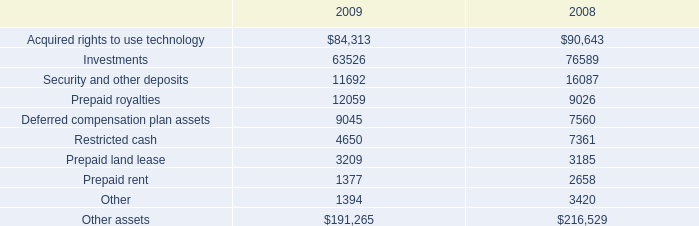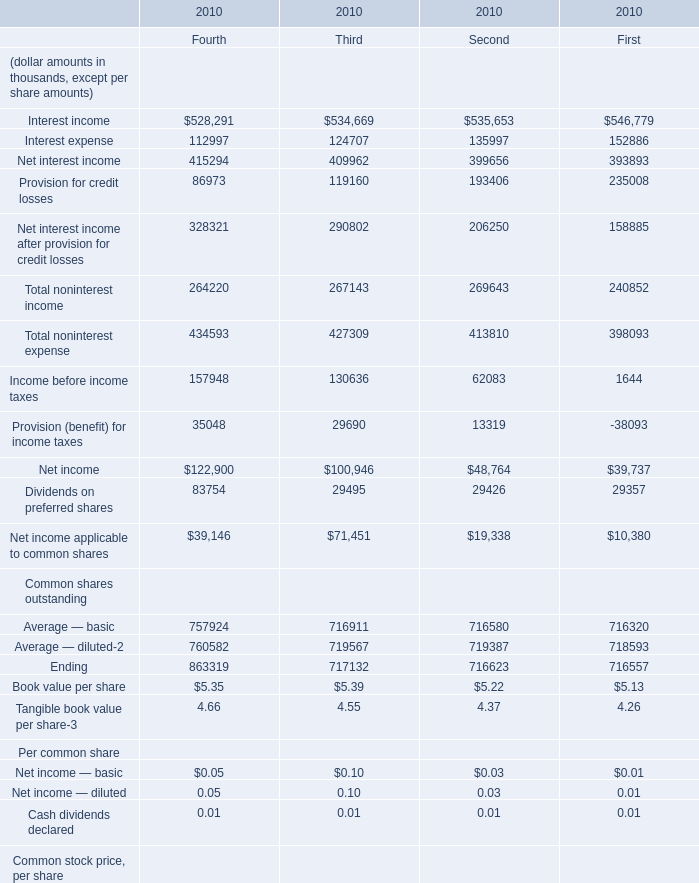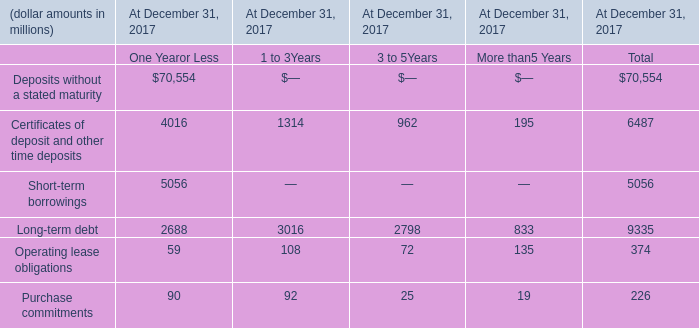what is the growth rate in the other assets from 2008 to 2009? 
Computations: ((191265 - 216529) / 216529)
Answer: -0.11668. 